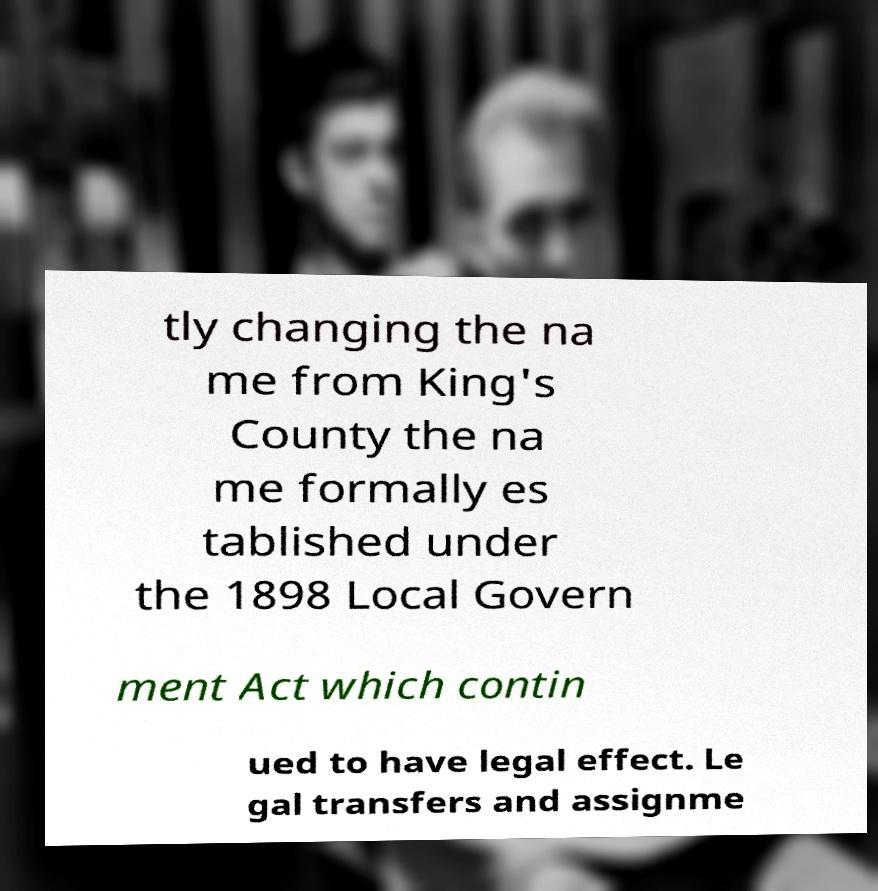Could you assist in decoding the text presented in this image and type it out clearly? tly changing the na me from King's County the na me formally es tablished under the 1898 Local Govern ment Act which contin ued to have legal effect. Le gal transfers and assignme 